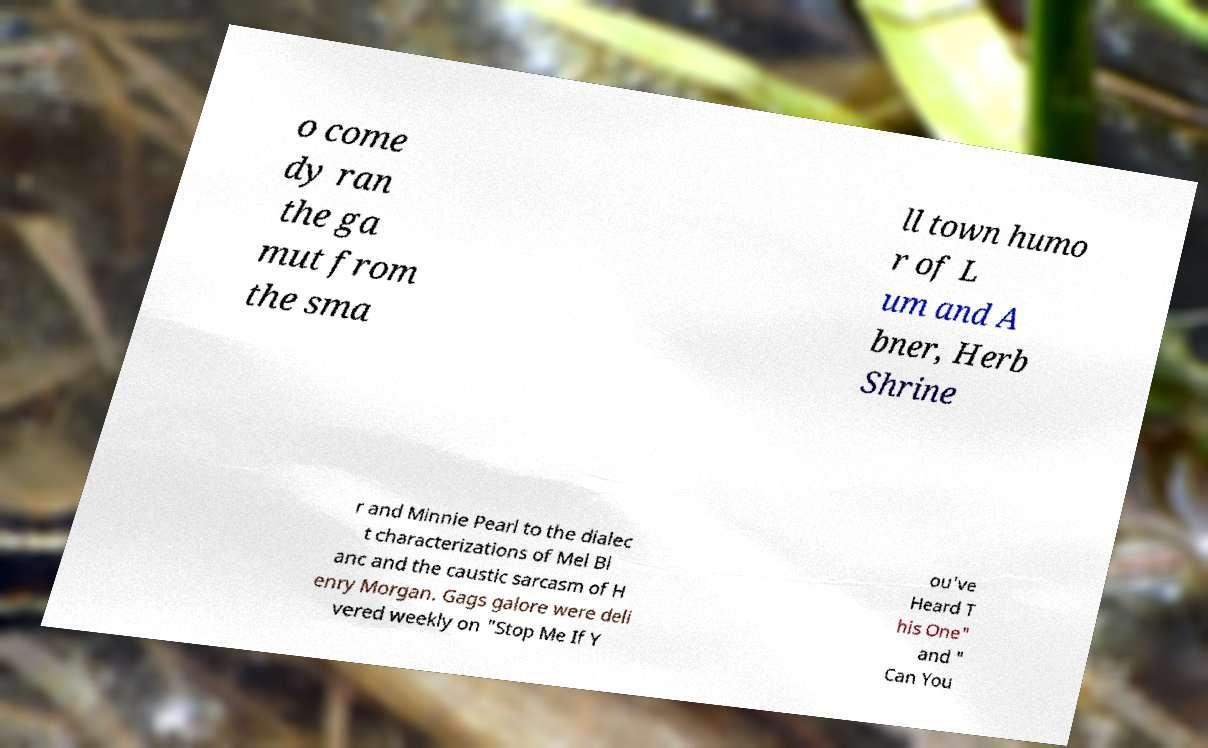Can you read and provide the text displayed in the image?This photo seems to have some interesting text. Can you extract and type it out for me? o come dy ran the ga mut from the sma ll town humo r of L um and A bner, Herb Shrine r and Minnie Pearl to the dialec t characterizations of Mel Bl anc and the caustic sarcasm of H enry Morgan. Gags galore were deli vered weekly on "Stop Me If Y ou've Heard T his One" and " Can You 